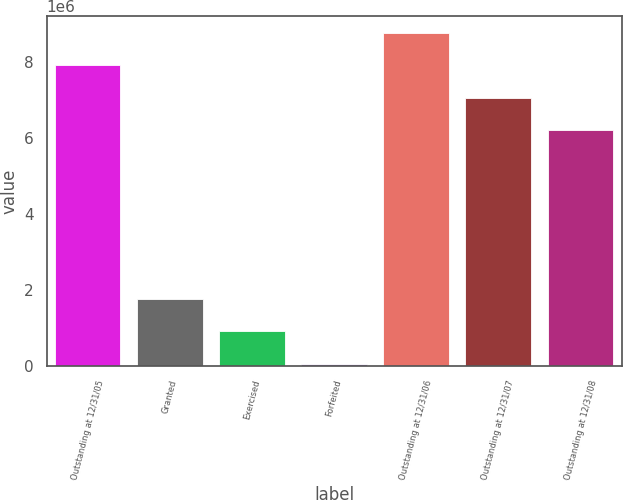Convert chart. <chart><loc_0><loc_0><loc_500><loc_500><bar_chart><fcel>Outstanding at 12/31/05<fcel>Granted<fcel>Exercised<fcel>Forfeited<fcel>Outstanding at 12/31/06<fcel>Outstanding at 12/31/07<fcel>Outstanding at 12/31/08<nl><fcel>7.91234e+06<fcel>1.77064e+06<fcel>914770<fcel>58900<fcel>8.76821e+06<fcel>7.05647e+06<fcel>6.2006e+06<nl></chart> 